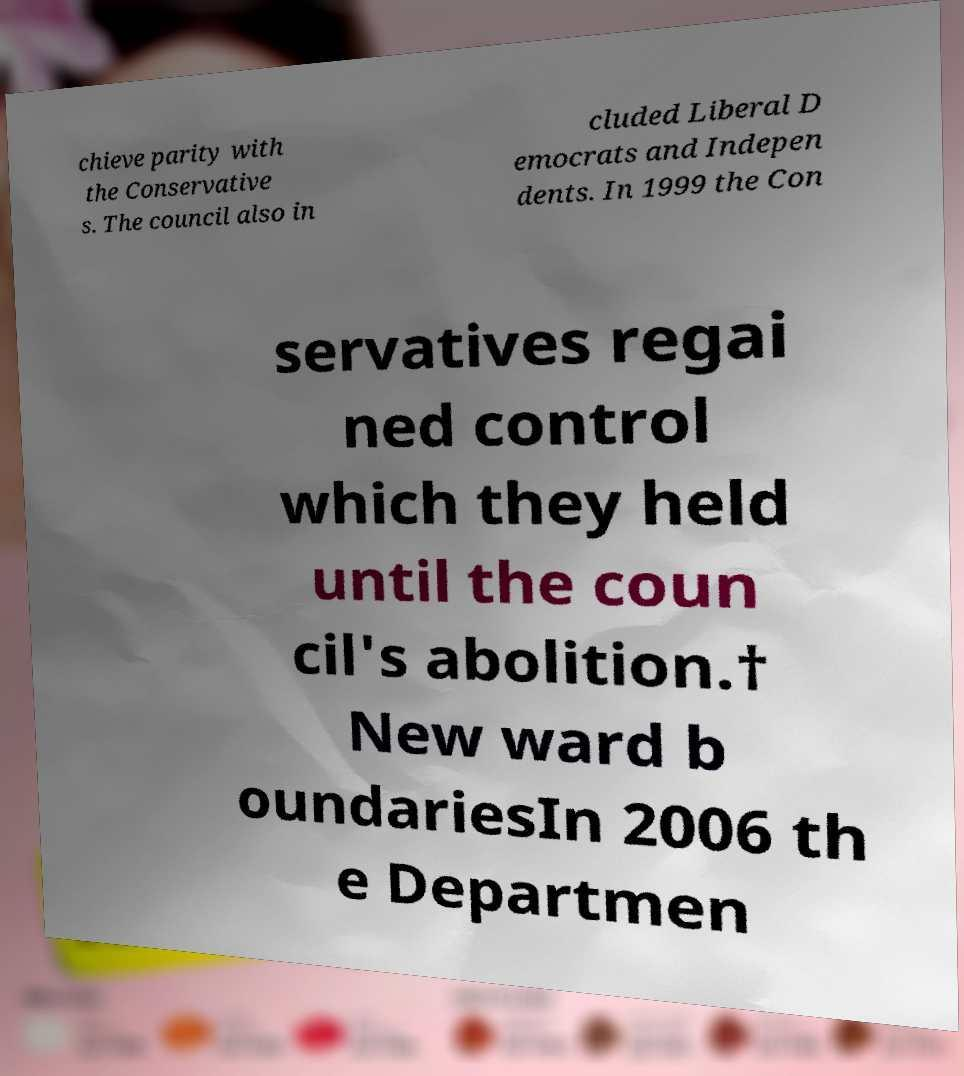For documentation purposes, I need the text within this image transcribed. Could you provide that? chieve parity with the Conservative s. The council also in cluded Liberal D emocrats and Indepen dents. In 1999 the Con servatives regai ned control which they held until the coun cil's abolition.† New ward b oundariesIn 2006 th e Departmen 